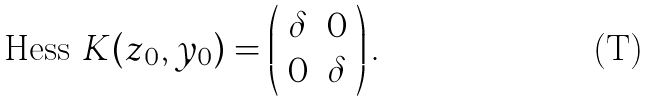Convert formula to latex. <formula><loc_0><loc_0><loc_500><loc_500>\text {Hess } K ( z _ { 0 } , y _ { 0 } ) = \left ( \begin{array} { c c } \delta & 0 \\ 0 & \delta \\ \end{array} \right ) .</formula> 